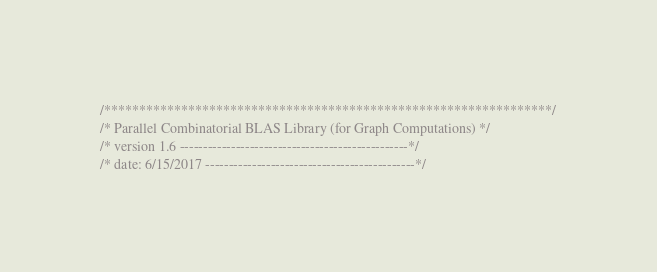<code> <loc_0><loc_0><loc_500><loc_500><_C_>/****************************************************************/
/* Parallel Combinatorial BLAS Library (for Graph Computations) */
/* version 1.6 -------------------------------------------------*/
/* date: 6/15/2017 ---------------------------------------------*/</code> 